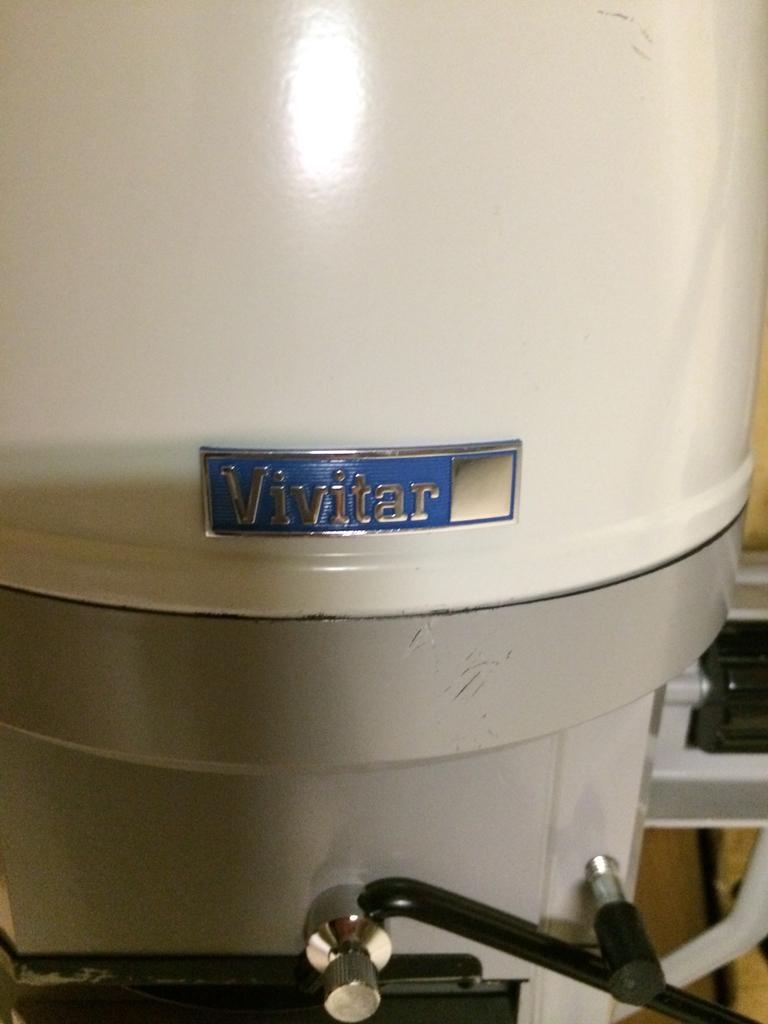<image>
Share a concise interpretation of the image provided. a white and grey machine with a label that says 'vivitar' on it 